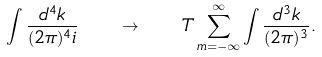<formula> <loc_0><loc_0><loc_500><loc_500>\int \frac { d ^ { 4 } k } { ( 2 \pi ) ^ { 4 } i } \quad \rightarrow \quad T \sum _ { m = - \infty } ^ { \infty } \int \frac { d ^ { 3 } k } { ( 2 \pi ) ^ { 3 } } .</formula> 